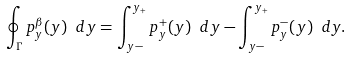<formula> <loc_0><loc_0><loc_500><loc_500>\oint _ { \Gamma } p _ { y } ^ { \beta } ( y ) \ d y = \int ^ { y _ { + } } _ { y - } p ^ { + } _ { y } ( y ) \ d y - \int ^ { y _ { + } } _ { y - } p ^ { - } _ { y } ( y ) \ d y .</formula> 